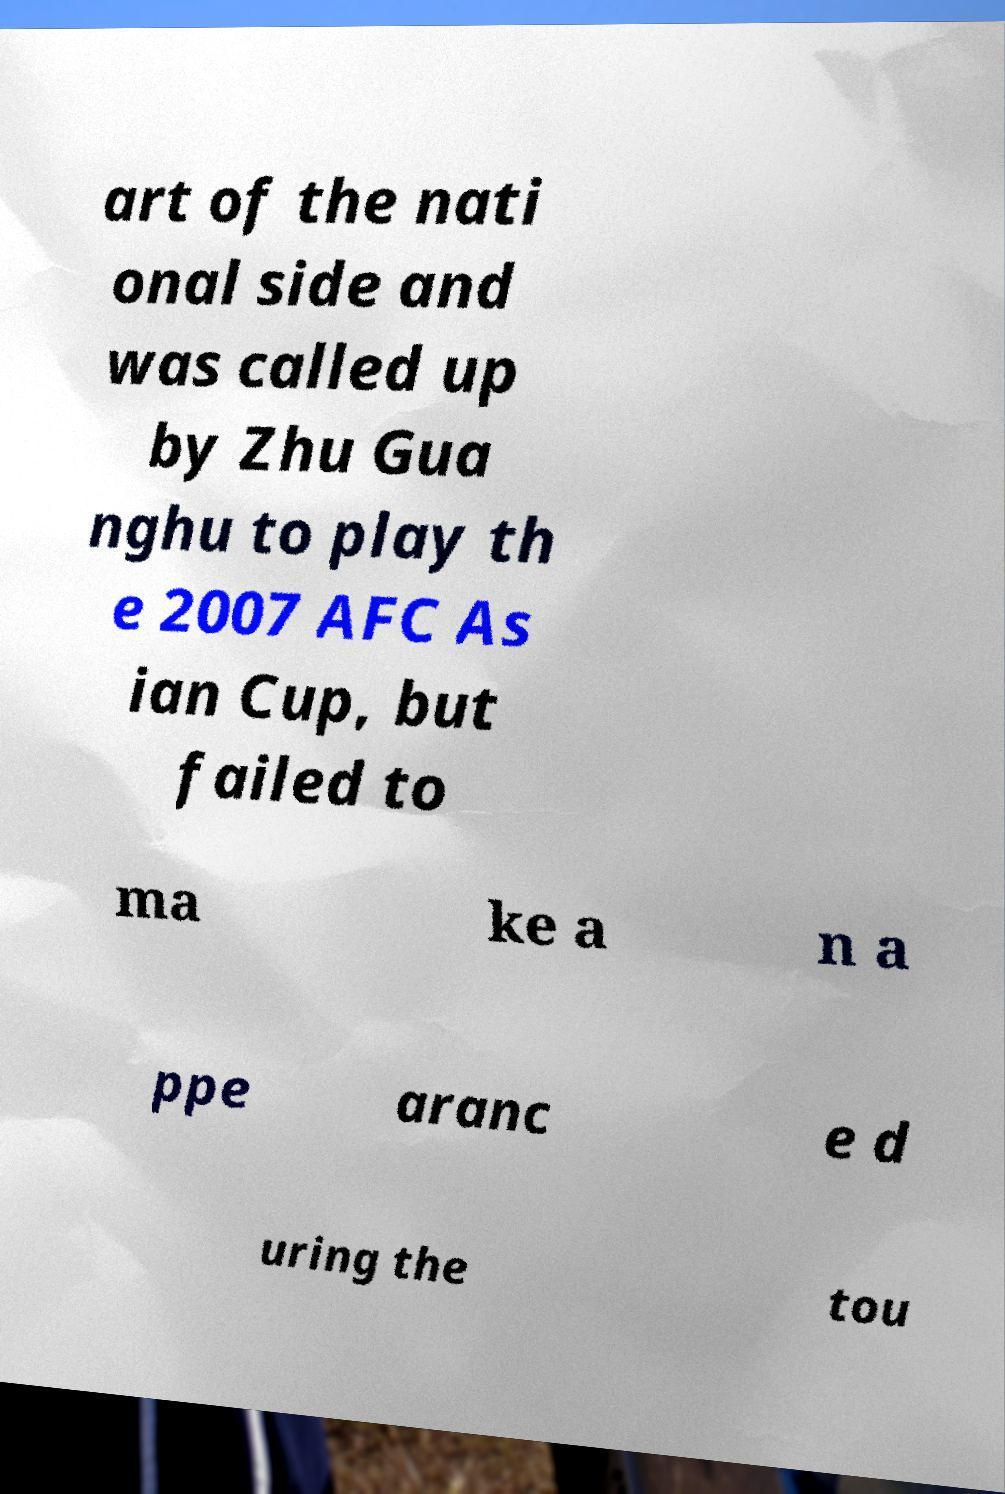Could you extract and type out the text from this image? art of the nati onal side and was called up by Zhu Gua nghu to play th e 2007 AFC As ian Cup, but failed to ma ke a n a ppe aranc e d uring the tou 